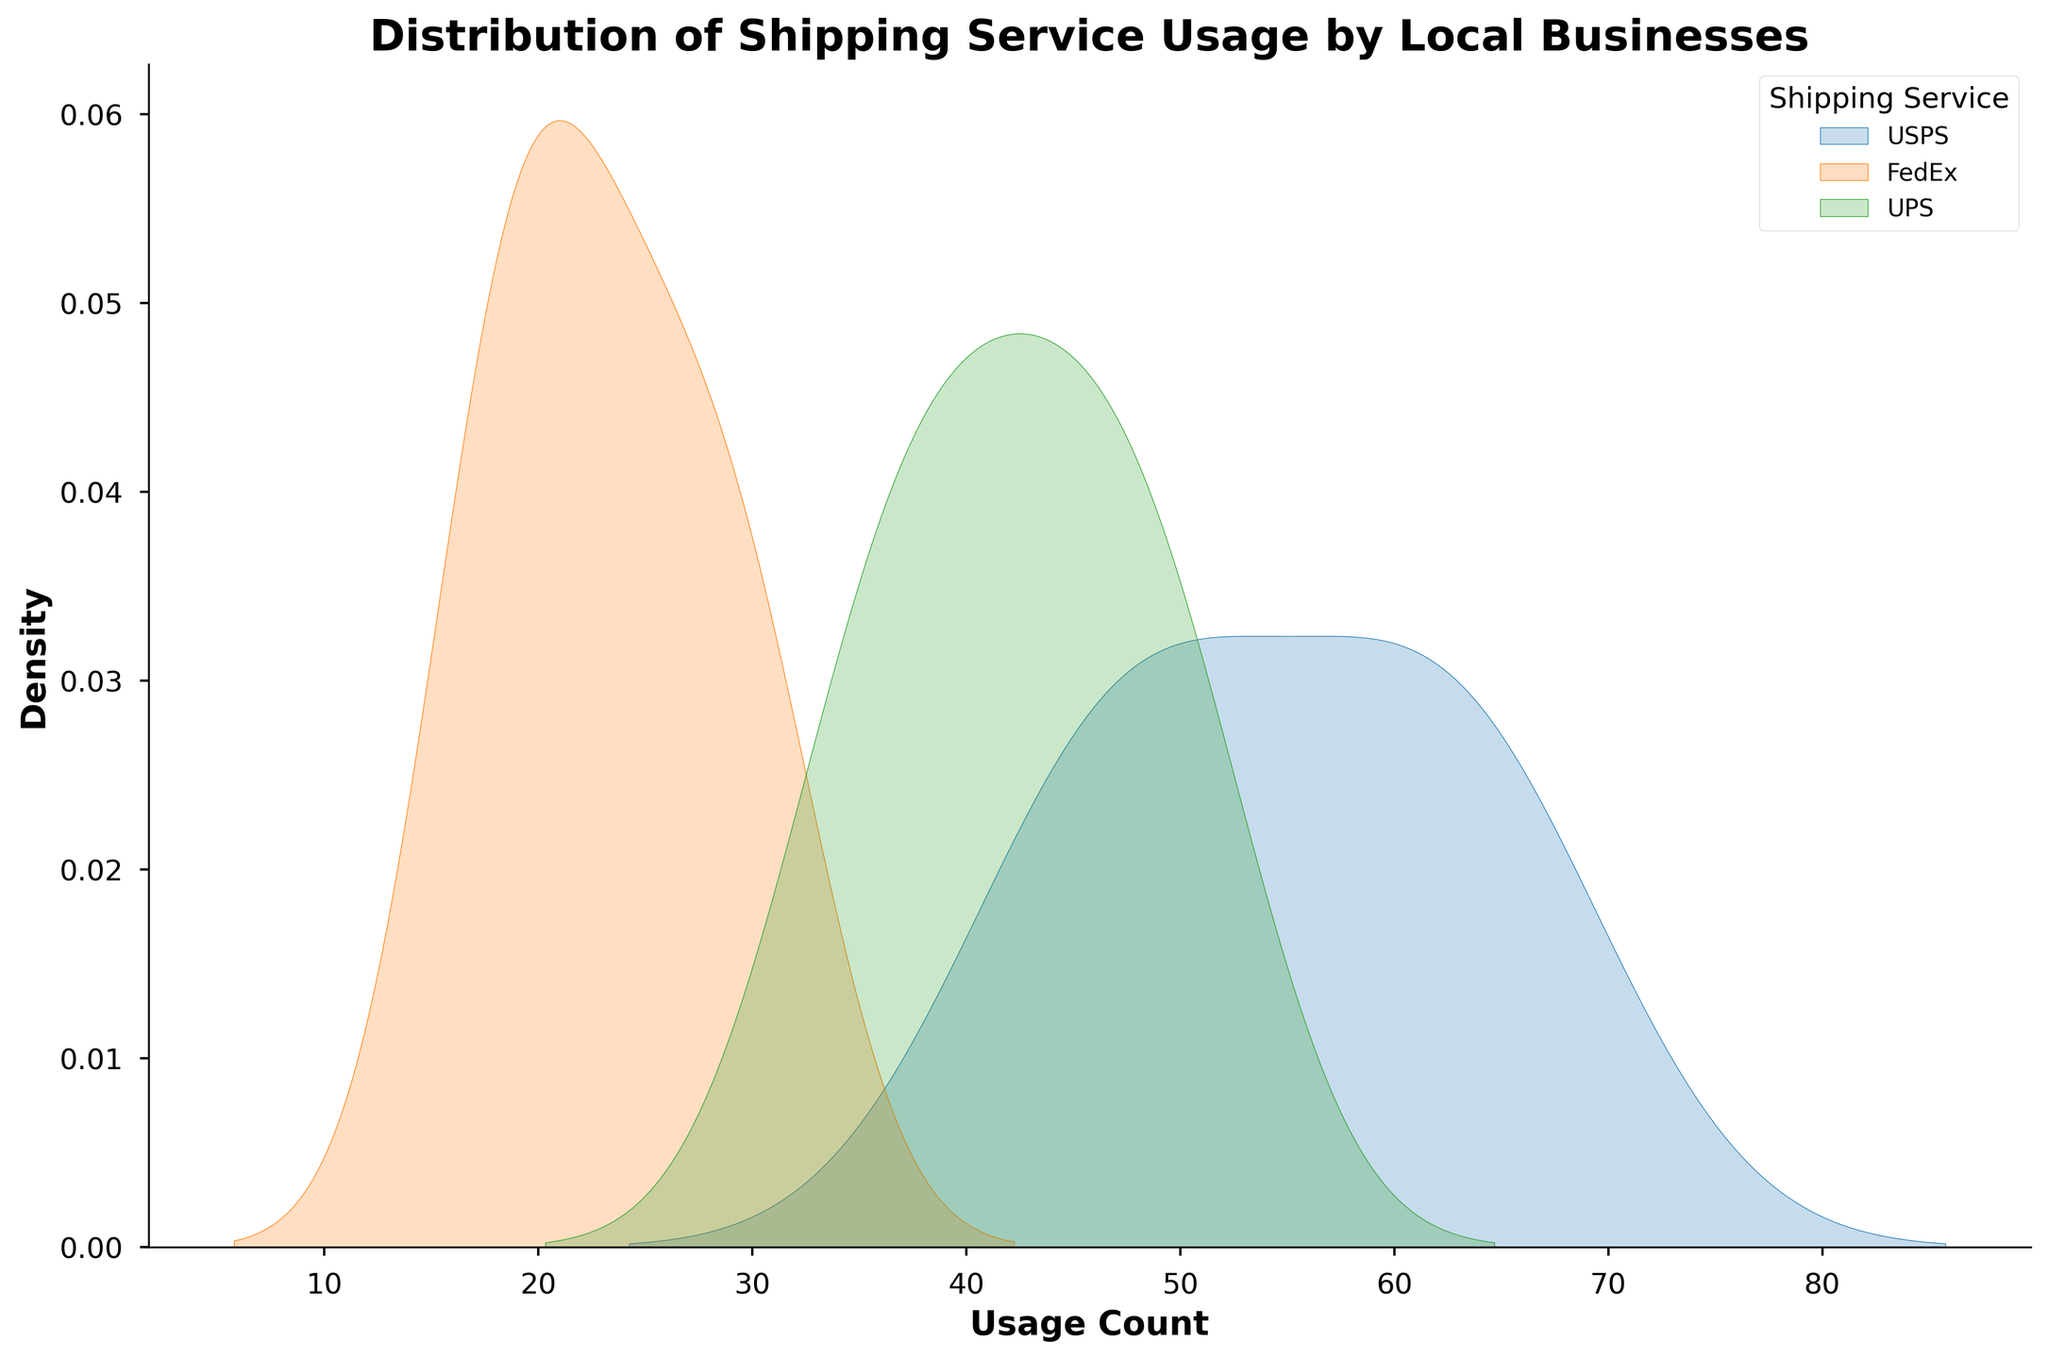What is the title of the figure? The title of the figure is displayed at the top and summarizes the content being shown. It reads as: "Distribution of Shipping Service Usage by Local Businesses".
Answer: Distribution of Shipping Service Usage by Local Businesses What is the range of usage counts for USPS? To determine the range, examine the horizontal axis and note the minimum and maximum values for USPS's density curve. The curve appears to start close to 45 and ends around 65.
Answer: 45 to 65 Which shipping service shows the highest density peak? By examining the height of the density curves, the service with the highest peak indicates the mode of that service. USPS appears to have the highest peak when compared to FedEx and UPS.
Answer: USPS For UPS, what can be said about the spread of its usage counts compared to USPS? Compare the width of the density curves of UPS and USPS. A wider curve indicates greater spread or variability in the usage counts, whereas a narrower curve indicates less spread.
Answer: UPS has a wider spread than USPS What is the approximate median usage count for FedEx? The median can be approximated by finding the midpoint of the curve’s area. For FedEx, the density curve centers around the value between 20 and 30, which appears to be around 25.
Answer: 25 Between USPS, FedEx, and UPS, which service has the most consistent (least spread-out) usage? Consistency can be observed by the narrowness of the density curves. The narrower the curve, the more consistent the usage. USPS has the narrowest curve.
Answer: USPS Which shipping service has the broadest range of usage counts? Look at the width of the density curves. A broader range implies a wider base of the curve. UPS shows the broadest range of values stretching roughly from 35 to 50.
Answer: UPS How do the peaks of FedEx and UPS compare in terms of their height? To compare the peaks' height, visually assess the maximum points of the density curves for both FedEx and UPS. FedEx's peak appears lower than UPS's peak.
Answer: FedEx peak < UPS peak 